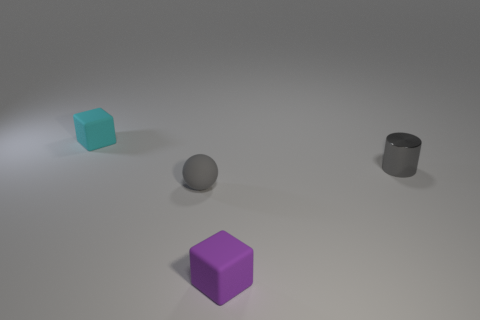Add 3 gray matte things. How many objects exist? 7 Subtract all balls. How many objects are left? 3 Subtract 0 blue blocks. How many objects are left? 4 Subtract all metal cylinders. Subtract all gray objects. How many objects are left? 1 Add 2 metallic objects. How many metallic objects are left? 3 Add 1 tiny purple matte objects. How many tiny purple matte objects exist? 2 